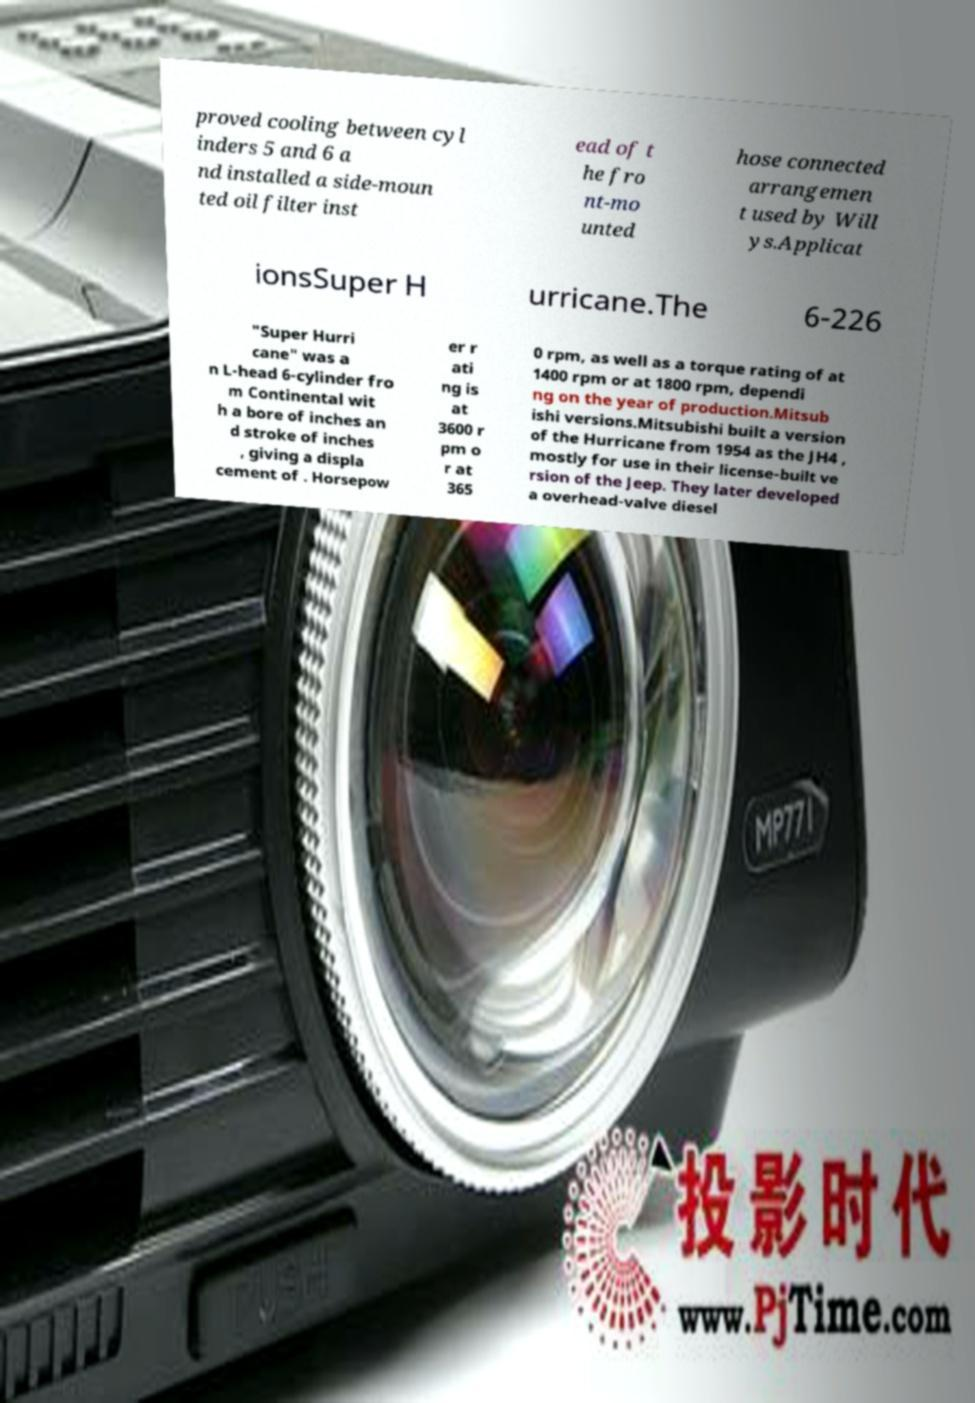Can you read and provide the text displayed in the image?This photo seems to have some interesting text. Can you extract and type it out for me? proved cooling between cyl inders 5 and 6 a nd installed a side-moun ted oil filter inst ead of t he fro nt-mo unted hose connected arrangemen t used by Will ys.Applicat ionsSuper H urricane.The 6-226 "Super Hurri cane" was a n L-head 6-cylinder fro m Continental wit h a bore of inches an d stroke of inches , giving a displa cement of . Horsepow er r ati ng is at 3600 r pm o r at 365 0 rpm, as well as a torque rating of at 1400 rpm or at 1800 rpm, dependi ng on the year of production.Mitsub ishi versions.Mitsubishi built a version of the Hurricane from 1954 as the JH4 , mostly for use in their license-built ve rsion of the Jeep. They later developed a overhead-valve diesel 